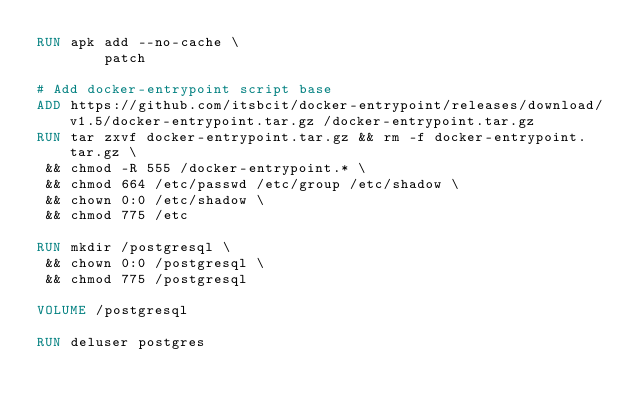Convert code to text. <code><loc_0><loc_0><loc_500><loc_500><_Dockerfile_>RUN apk add --no-cache \
        patch

# Add docker-entrypoint script base
ADD https://github.com/itsbcit/docker-entrypoint/releases/download/v1.5/docker-entrypoint.tar.gz /docker-entrypoint.tar.gz
RUN tar zxvf docker-entrypoint.tar.gz && rm -f docker-entrypoint.tar.gz \
 && chmod -R 555 /docker-entrypoint.* \
 && chmod 664 /etc/passwd /etc/group /etc/shadow \
 && chown 0:0 /etc/shadow \
 && chmod 775 /etc

RUN mkdir /postgresql \
 && chown 0:0 /postgresql \
 && chmod 775 /postgresql

VOLUME /postgresql

RUN deluser postgres
</code> 